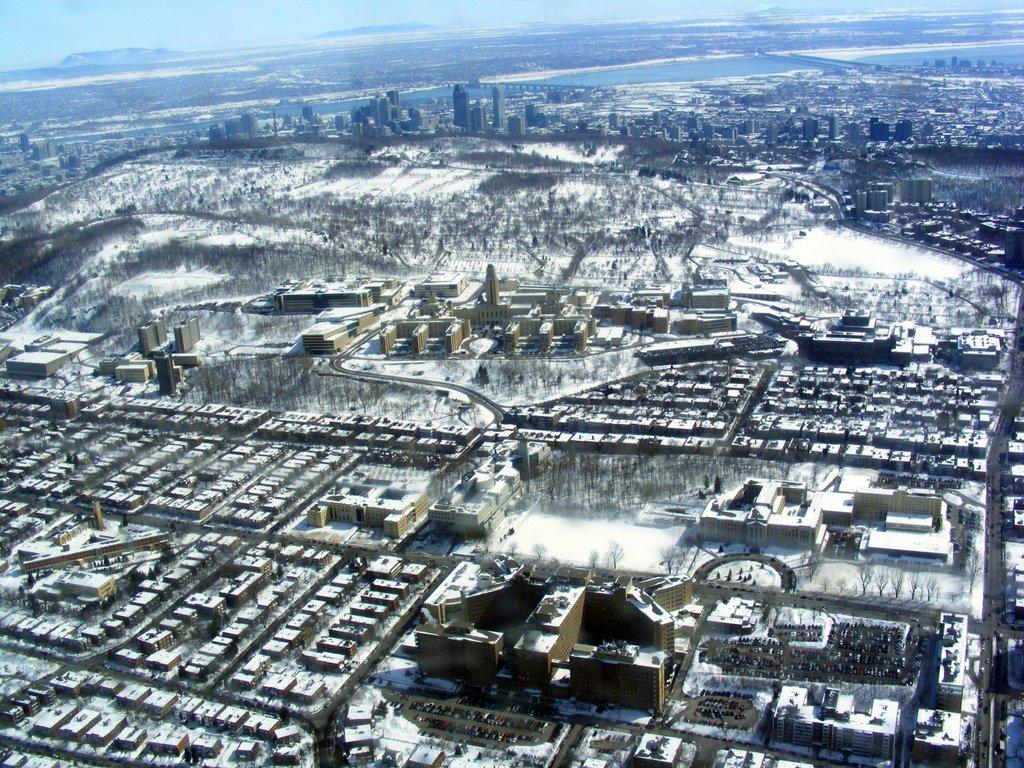What type of structures can be seen in the image? There are buildings in the image. What is the weather like in the image? There is snow visible in the image, indicating a cold and likely wintery scene. What can be seen in the background of the image? There is water visible in the background of the image. What type of landscape feature is present in the image? There are hills in the image. Where is the cellar located in the image? There is no cellar present in the image. What type of prose can be read in the image? There is no text or prose visible in the image. 